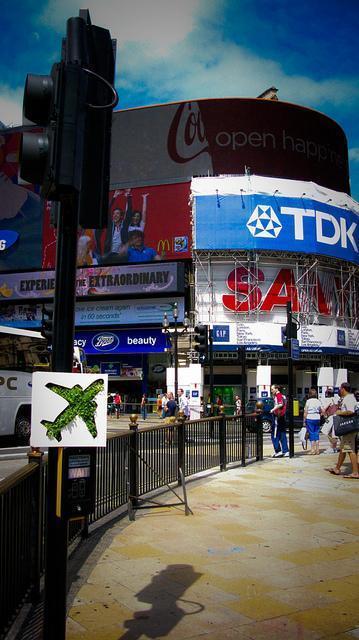How many traffic lights can you see?
Give a very brief answer. 1. 